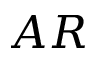Convert formula to latex. <formula><loc_0><loc_0><loc_500><loc_500>A R</formula> 